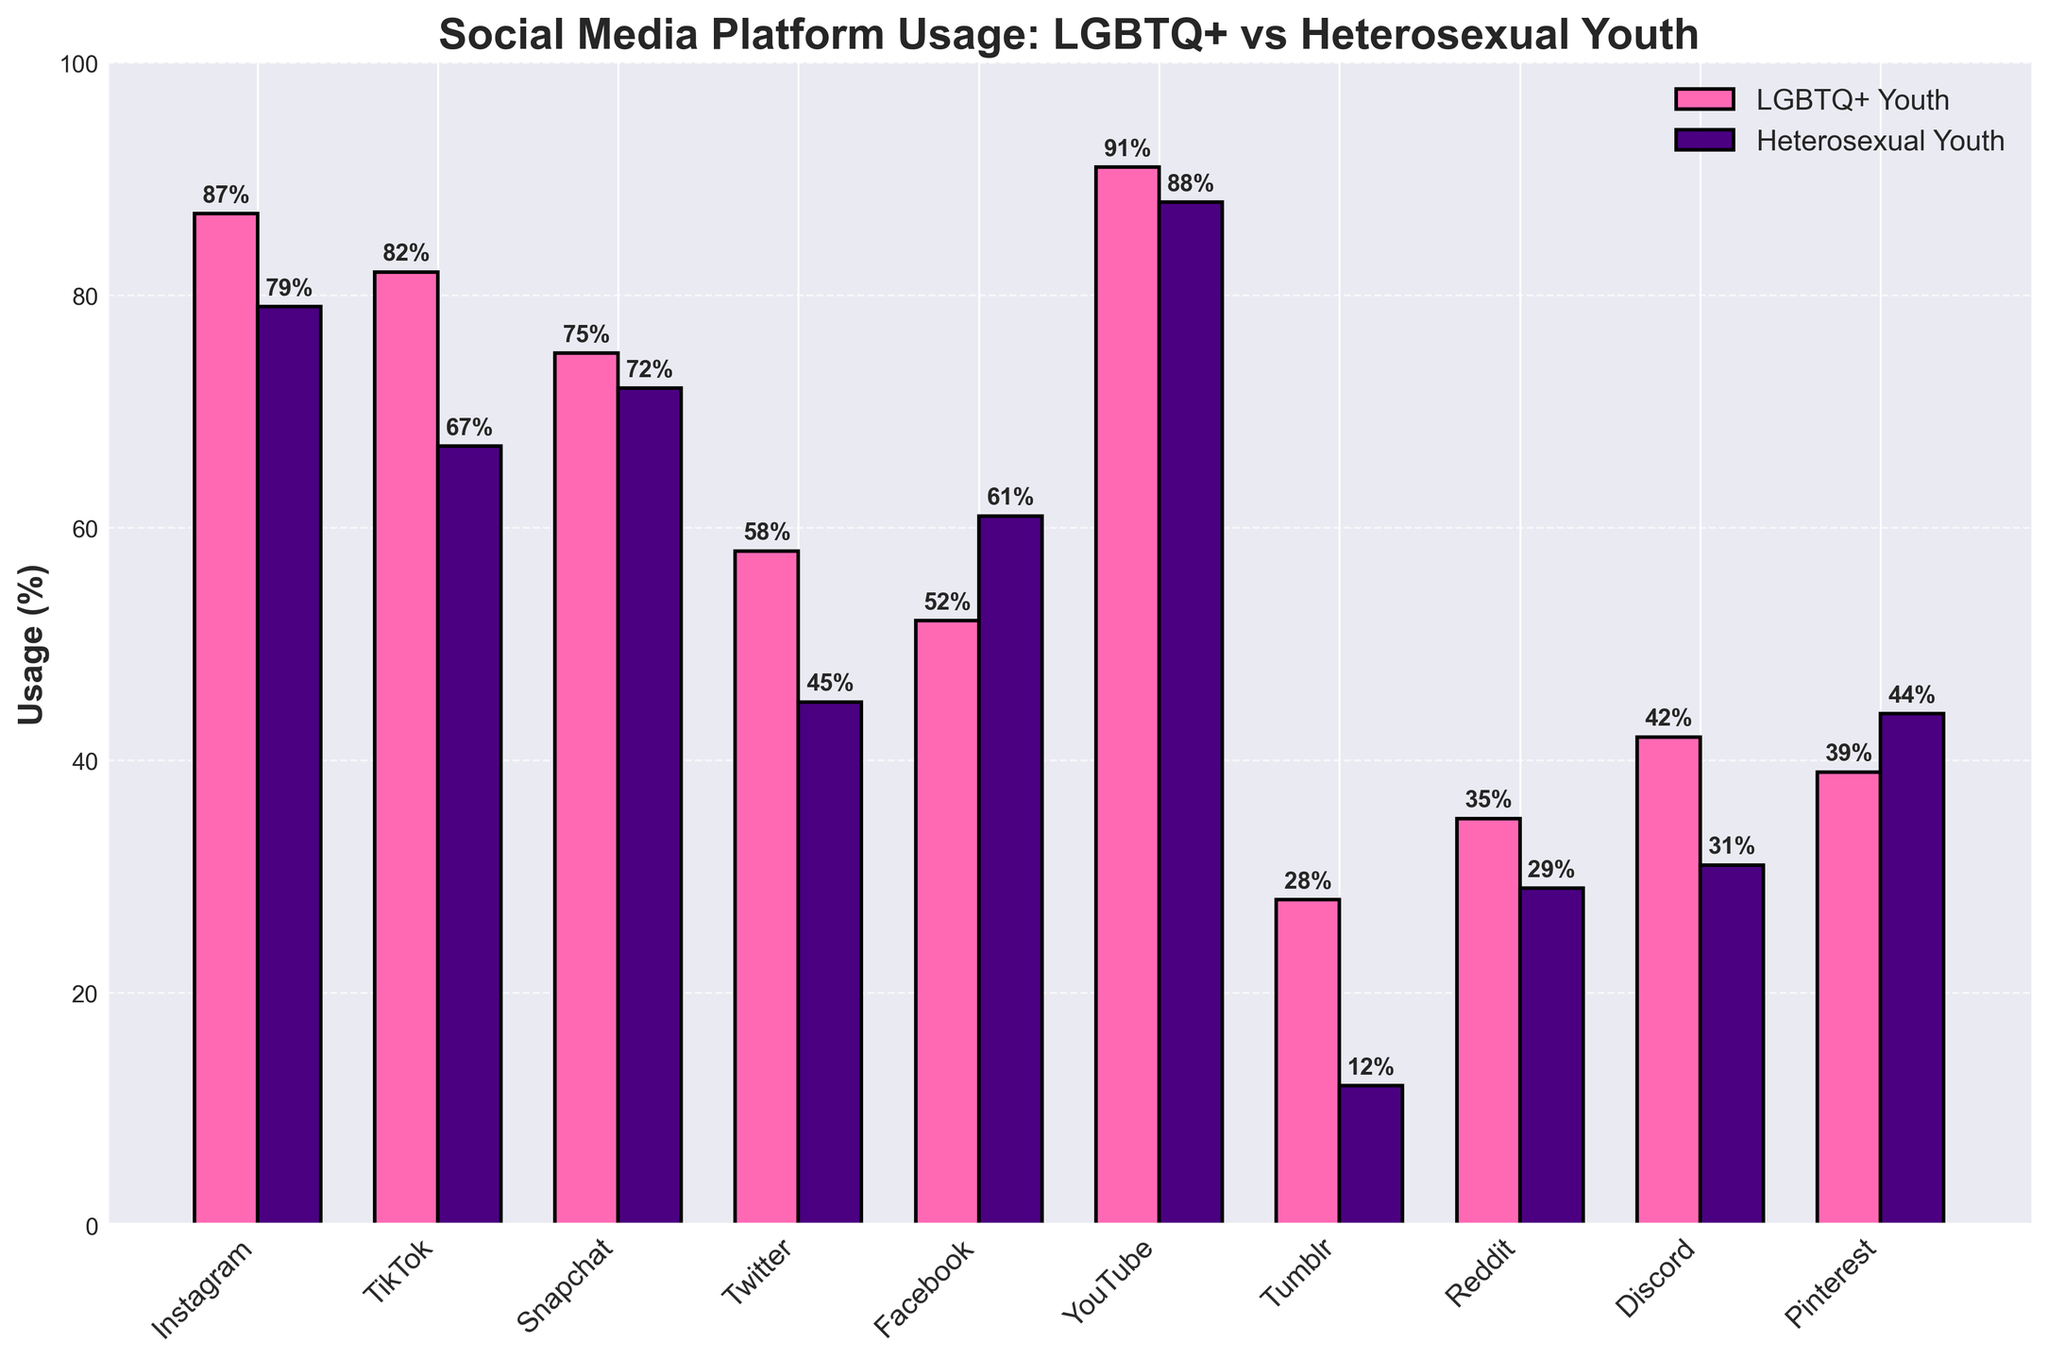Which social media platform has the highest usage among LGBTQ+ youth? Based on the bar chart, look for the bar representing the highest percentage usage among LGBTQ+ youth. YouTube has the highest bar at 91%.
Answer: YouTube Which platform has the biggest difference in usage between LGBTQ+ and heterosexual youth? Calculate the absolute difference in usage percentages between LGBTQ+ and heterosexual youth for each platform. Tumblr has the largest difference with 28% for LGBTQ+ and 12% for heterosexual, a difference of 16%.
Answer: Tumblr How does Facebook usage among heterosexual youth compare to that among LGBTQ+ youth? Examine the heights of the bars representing Facebook usage for both groups. Heterosexual youth usage (61%) is higher than LGBTQ+ youth usage (52%).
Answer: Higher What is the combined average usage of TikTok and Twitter among LGBTQ+ youth? Calculate the average by adding the usage percentages for TikTok (82%) and Twitter (58%) and then dividing by 2: (82 + 58) / 2 = 70.
Answer: 70% Which platform has the smallest difference in usage between the two groups? Calculate the absolute difference for each platform and find the smallest value. Snapchat has a small difference of 3% (75% LGBTQ+ vs 72% heterosexual).
Answer: Snapchat Is the usage of Discord higher among LGBTQ+ youth or heterosexual youth? Compare the heights of the bars for Discord usage in the two groups. LGBTQ+ youth usage is higher at 42% compared to heterosexual youth usage at 31%.
Answer: LGBTQ+ youth What is the total usage percentage for Pinterest among both groups? Add the usage percentages for Pinterest for LGBTQ+ (39%) and heterosexual (44%) youth: 39 + 44 = 83.
Answer: 83% Which group uses Instagram more, and by what percentage? Compare the heights of the Instagram bars. LGBTQ+ youth usage (87%) is higher than heterosexual youth usage (79%). The difference is 87 - 79 = 8%.
Answer: LGBTQ+ youth, 8% How does the usage of Tumblr among LGBTQ+ youth compare to all other platforms for the same group? Look at the height of the Tumblr bar for LGBTQ+ youth (28%) and compare it to the other platforms' bars for the same group. Tumblr is the least used platform by LGBTQ+ youth.
Answer: Least used Find the average usage of all listed platforms among heterosexual youth. Calculate the average by summing usage percentages for all platforms and dividing by the number of platforms: (79 + 67 + 72 + 45 + 61 + 88 + 12 + 29 + 31 + 44) / 10 ≈ 52.8.
Answer: 52.8 